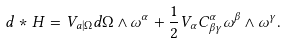<formula> <loc_0><loc_0><loc_500><loc_500>d * H = V _ { a | \Omega } d \Omega \wedge \omega ^ { \alpha } + \frac { 1 } { 2 } V _ { \alpha } C _ { \beta \gamma } ^ { \alpha } \omega ^ { \beta } \wedge \omega ^ { \gamma } .</formula> 